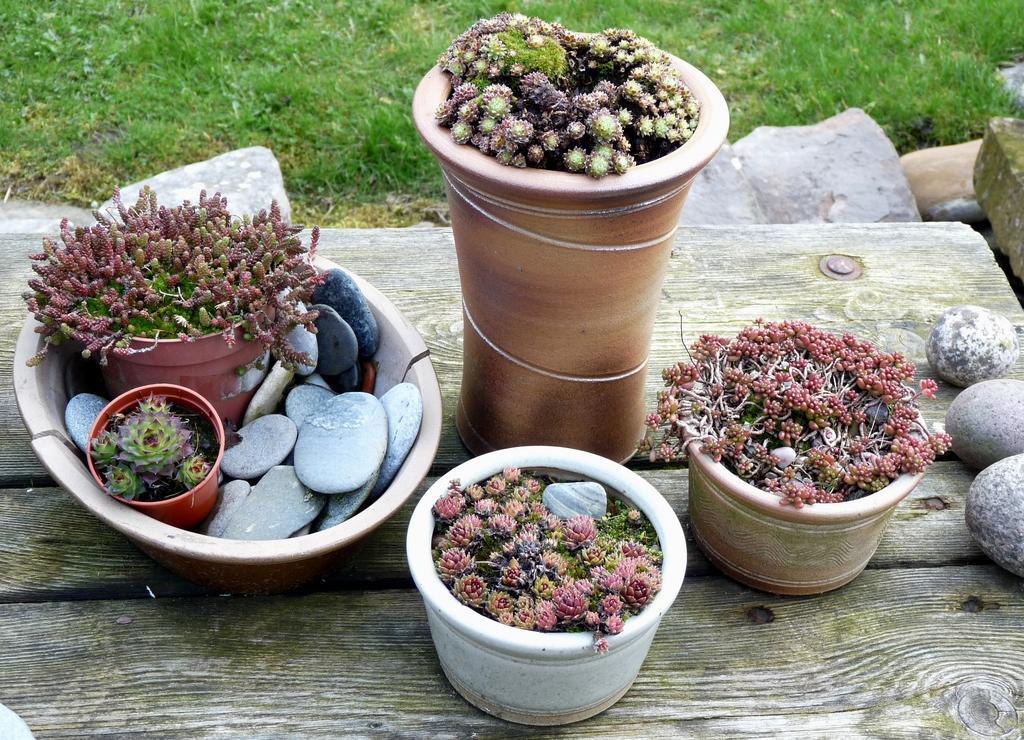Could you give a brief overview of what you see in this image? In this image there are flower pots on a wooden surface. To the left there is a tub. There are pebbles and flower pots in the tub. At the top there is the grass. To the right there are pebbles on the wooden surface. 